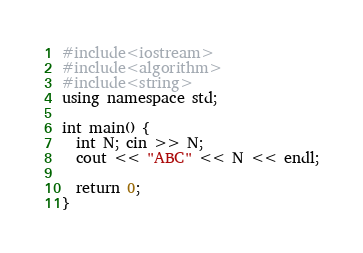Convert code to text. <code><loc_0><loc_0><loc_500><loc_500><_C++_>#include<iostream>
#include<algorithm>
#include<string>
using namespace std;

int main() {
  int N; cin >> N;
  cout << "ABC" << N << endl;

  return 0;
}
</code> 